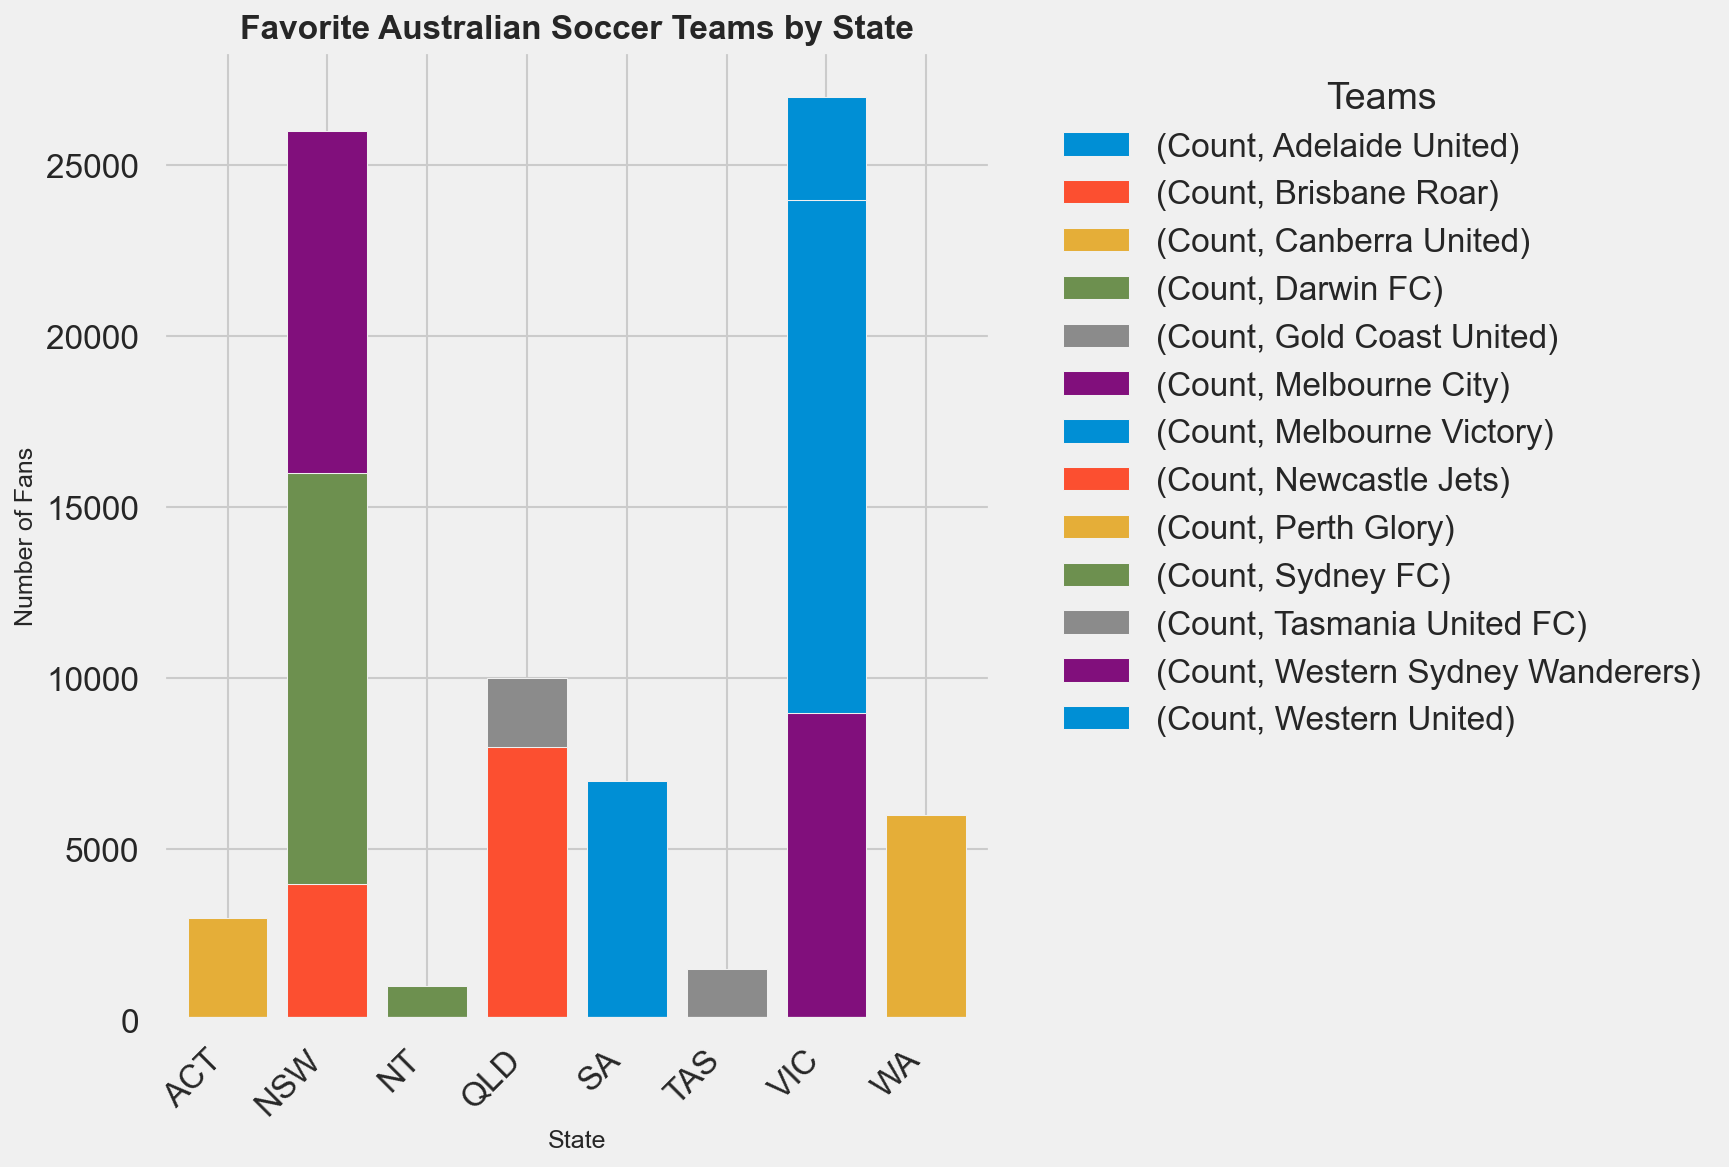Which state has the highest number of fans for Melbourne Victory? To find the state with the highest number of fans for Melbourne Victory, look for the height of the bar corresponding to Melbourne Victory in each state. Melbourne Victory can be found highest in Victoria (VIC) with 15,000 fans.
Answer: Victoria Which team has the least fans in New South Wales (NSW)? To determine which team has the least fans in NSW, examine the bars for each team in NSW. The smallest bar in NSW corresponds to the Newcastle Jets with 4,000 fans.
Answer: Newcastle Jets How many fans are there in total for teams in Queensland (QLD)? Add the number of fans for each team in QLD. Brisbane Roar has 8,000 fans and Gold Coast United has 2,000 fans, making a total of 8,000 + 2,000 = 10,000 fans.
Answer: 10,000 Which state has the highest fan count for a single team, and what is that team? Look for the highest single bar in the chart across all states. The highest single bar is for Melbourne Victory in Victoria (VIC) with 15,000 fans.
Answer: Victoria, Melbourne Victory Compare the total number of fans for teams in Victoria (VIC) to those in New South Wales (NSW). Which state has more fans? Sum the fans in VIC and NSW separately. VIC has 15,000 + 9,000 + 3,000 = 27,000 fans; NSW has 12,000 + 10,000 + 4,000 = 26,000 fans. VIC has more fans than NSW.
Answer: Victoria What is the combined number of fans for Adelaide United and Perth Glory? Add the fans for Adelaide United and Perth Glory. Adelaide United has 7,000 fans and Perth Glory has 6,000 fans, making a total of 7,000 + 6,000 = 13,000 fans.
Answer: 13,000 Which team has the largest number of fans in the Australian Capital Territory (ACT)? Look at the bar corresponding to Canberra United in ACT. Canberra United is the only team in ACT with 3,000 fans.
Answer: Canberra United In which state does the team Tasmania United FC have fans, and how many fans are there? Identify the state where Tasmania United FC is listed and check the height of the bar. Tasmania United FC has a bar in Tasmania with 1,500 fans.
Answer: Tasmania, 1,500 Is the number of fans for Western Sydney Wanderers more than the total number of fans for all teams in Northern Territory (NT)? Western Sydney Wanderers has 10,000 fans. NT has only Darwin FC with 1,000 fans. Therefore, 10,000 (Western Sydney Wanderers) is more than 1,000 (NT total).
Answer: Yes 